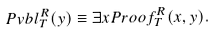<formula> <loc_0><loc_0><loc_500><loc_500>P v b l _ { T } ^ { R } ( y ) \equiv \exists x P r o o f _ { T } ^ { R } ( x , y ) .</formula> 